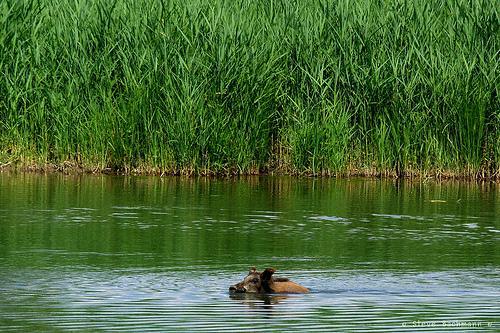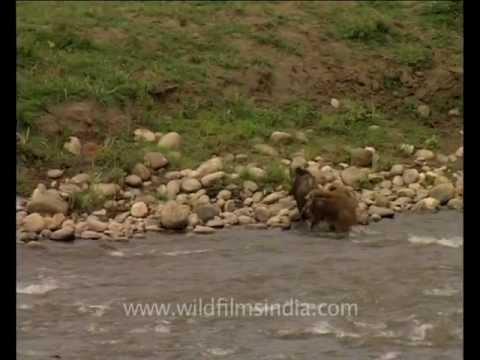The first image is the image on the left, the second image is the image on the right. For the images displayed, is the sentence "In the image on the left there is one boar swimming in the water." factually correct? Answer yes or no. Yes. The first image is the image on the left, the second image is the image on the right. For the images shown, is this caption "The left image contains one wild pig swimming leftward, with tall grass on the water's edge behind him." true? Answer yes or no. Yes. 